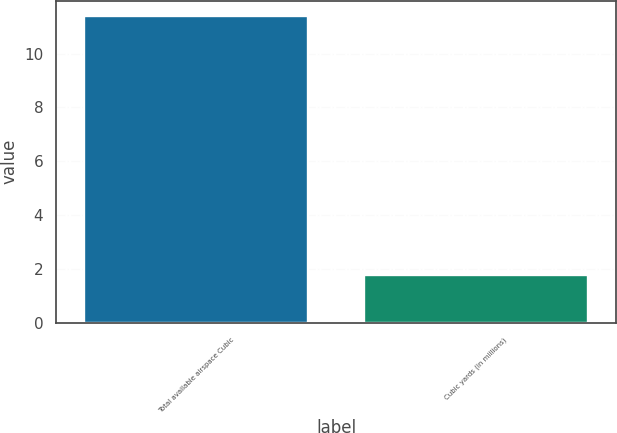Convert chart. <chart><loc_0><loc_0><loc_500><loc_500><bar_chart><fcel>Total available airspace Cubic<fcel>Cubic yards (in millions)<nl><fcel>11.4<fcel>1.8<nl></chart> 